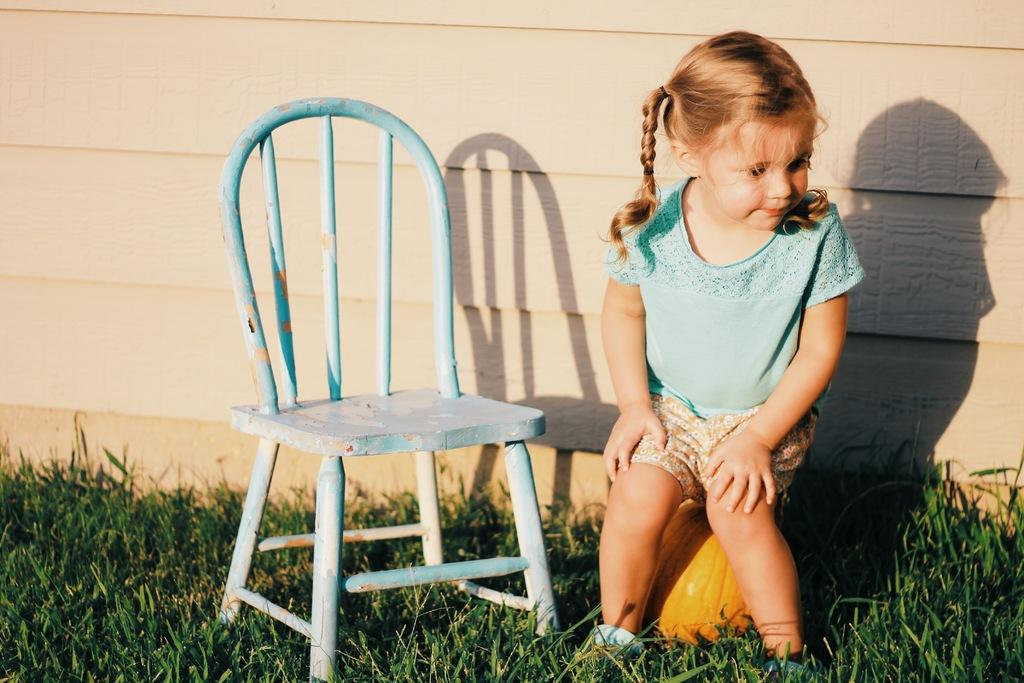What is the girl sitting on in the image? The girl is sitting on a pumpkin in the image. What can be seen on the grass in the image? There is a chair on the grass in the image. What is visible in the background of the image? There is a wall in the background of the image. How many icicles are hanging from the wall in the image? There are no icicles present in the image; it is not a cold or snowy scene. 